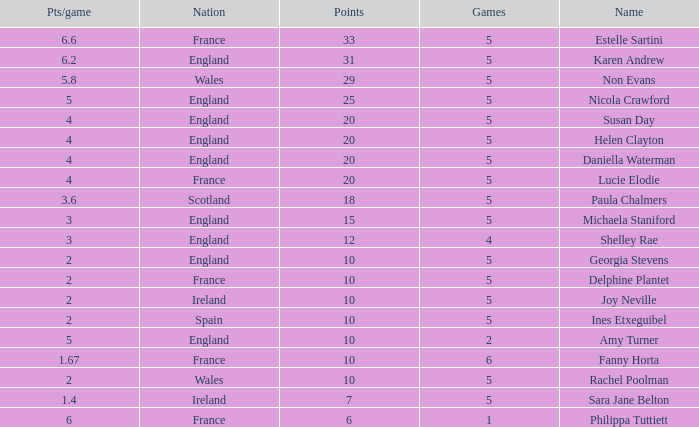Can you tell me the lowest Pts/game that has the Games larger than 6? None. 